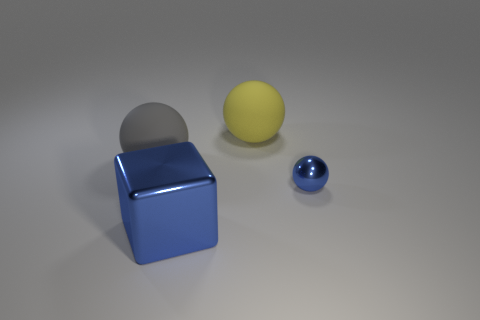Add 2 small metal blocks. How many objects exist? 6 Subtract all blocks. How many objects are left? 3 Subtract all tiny purple shiny things. Subtract all blue metal objects. How many objects are left? 2 Add 2 blue objects. How many blue objects are left? 4 Add 1 large gray metallic balls. How many large gray metallic balls exist? 1 Subtract 0 cyan spheres. How many objects are left? 4 